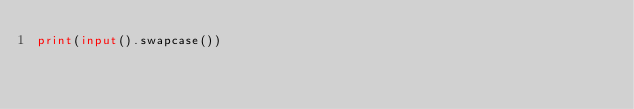<code> <loc_0><loc_0><loc_500><loc_500><_Python_>print(input().swapcase())

</code> 